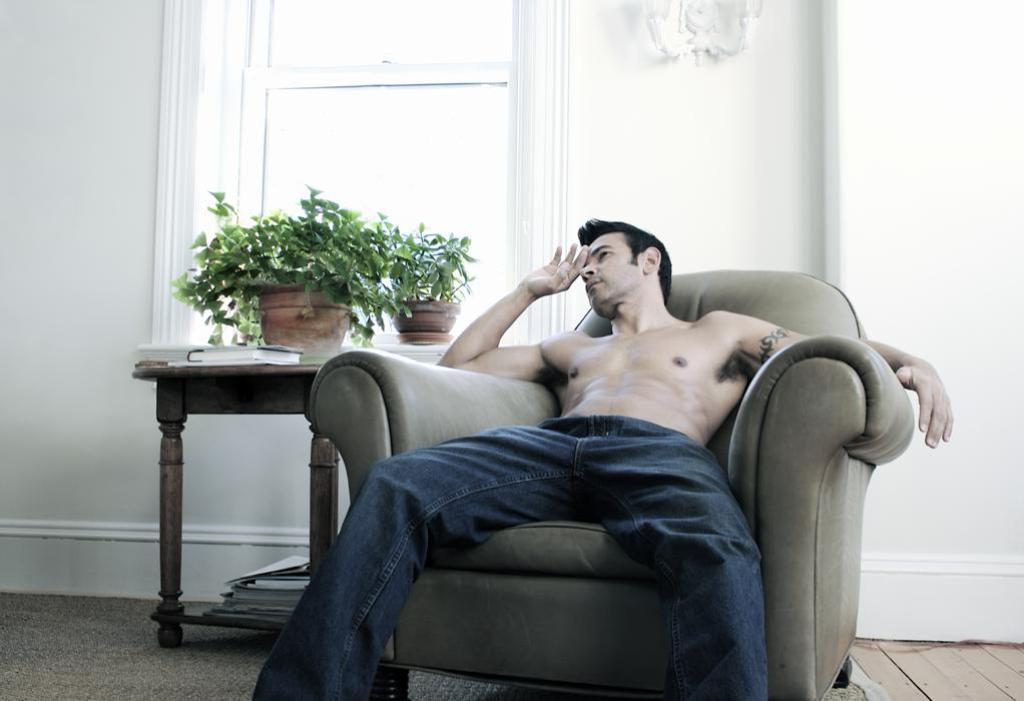What is the appearance of the person in the image? There is a shirtless guy in the image. What is the guy doing in the image? The guy is sitting on a chair or sofa. What is located to the left of the guy? There is a small plant to the left of the guy. What can be seen in the background of the image? There is a window in the background of the image. What type of drug is the guy holding in the image? There is no drug present in the image; the guy is shirtless and sitting on a chair or sofa. What color is the ink on the umbrella in the image? There is no umbrella present in the image. 